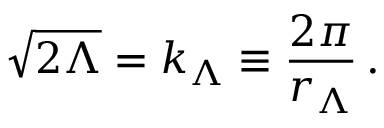<formula> <loc_0><loc_0><loc_500><loc_500>\sqrt { 2 \Lambda } = k _ { \Lambda } \equiv \frac { 2 \pi } { r _ { \Lambda } } \, .</formula> 